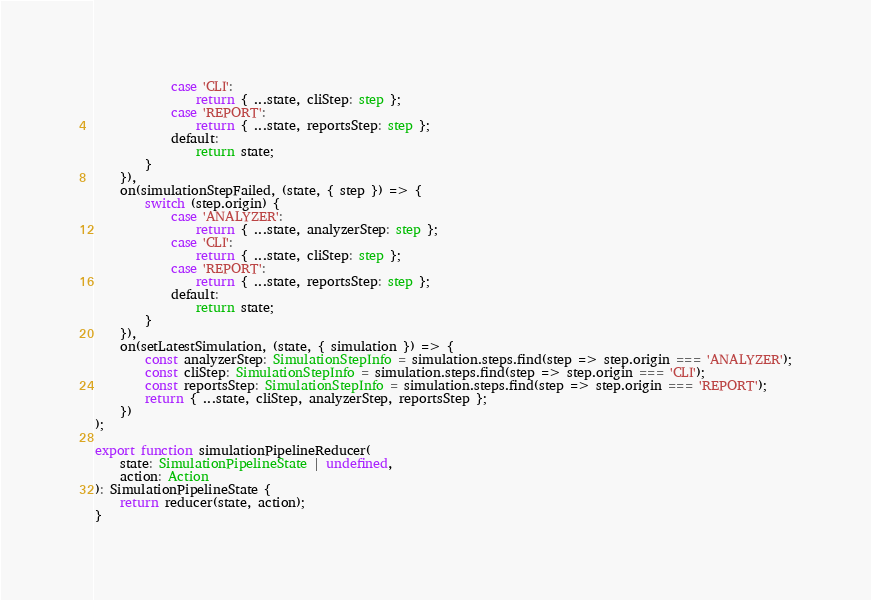<code> <loc_0><loc_0><loc_500><loc_500><_TypeScript_>            case 'CLI':
                return { ...state, cliStep: step };
            case 'REPORT':
                return { ...state, reportsStep: step };
            default:
                return state;
        }
    }),
    on(simulationStepFailed, (state, { step }) => {
        switch (step.origin) {
            case 'ANALYZER':
                return { ...state, analyzerStep: step };
            case 'CLI':
                return { ...state, cliStep: step };
            case 'REPORT':
                return { ...state, reportsStep: step };
            default:
                return state;
        }
    }),
    on(setLatestSimulation, (state, { simulation }) => {
        const analyzerStep: SimulationStepInfo = simulation.steps.find(step => step.origin === 'ANALYZER');
        const cliStep: SimulationStepInfo = simulation.steps.find(step => step.origin === 'CLI');
        const reportsStep: SimulationStepInfo = simulation.steps.find(step => step.origin === 'REPORT');
        return { ...state, cliStep, analyzerStep, reportsStep };
    })
);

export function simulationPipelineReducer(
    state: SimulationPipelineState | undefined,
    action: Action
): SimulationPipelineState {
    return reducer(state, action);
}
</code> 